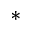<formula> <loc_0><loc_0><loc_500><loc_500>^ { * }</formula> 